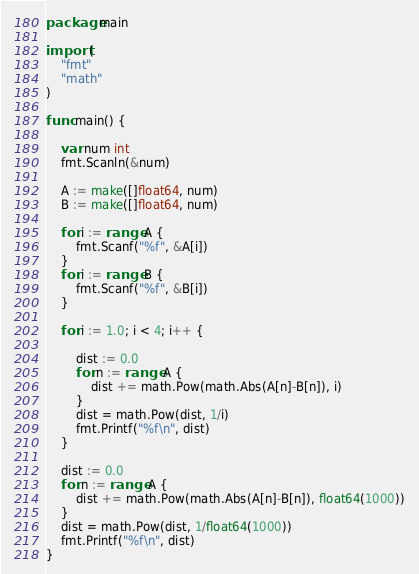Convert code to text. <code><loc_0><loc_0><loc_500><loc_500><_Go_>package main

import (
	"fmt"
	"math"
)

func main() {

	var num int
	fmt.Scanln(&num)

	A := make([]float64, num)
	B := make([]float64, num)

	for i := range A {
		fmt.Scanf("%f", &A[i])
	}
	for i := range B {
		fmt.Scanf("%f", &B[i])
	}

	for i := 1.0; i < 4; i++ {

		dist := 0.0
		for n := range A {
			dist += math.Pow(math.Abs(A[n]-B[n]), i)
		}
		dist = math.Pow(dist, 1/i)
		fmt.Printf("%f\n", dist)
	}

	dist := 0.0
	for n := range A {
		dist += math.Pow(math.Abs(A[n]-B[n]), float64(1000))
	}
	dist = math.Pow(dist, 1/float64(1000))
	fmt.Printf("%f\n", dist)
}

</code> 